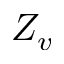Convert formula to latex. <formula><loc_0><loc_0><loc_500><loc_500>Z _ { v }</formula> 